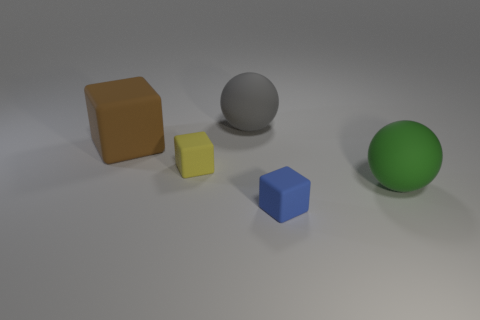Is there any specific pattern to how the objects are arranged? The objects appear to be arranged with intent, possibly to showcase their geometric differences. From our perspective, they form a diagonal line with increasing spacing between them from left to right, creating a sense of both order and progression through space. 